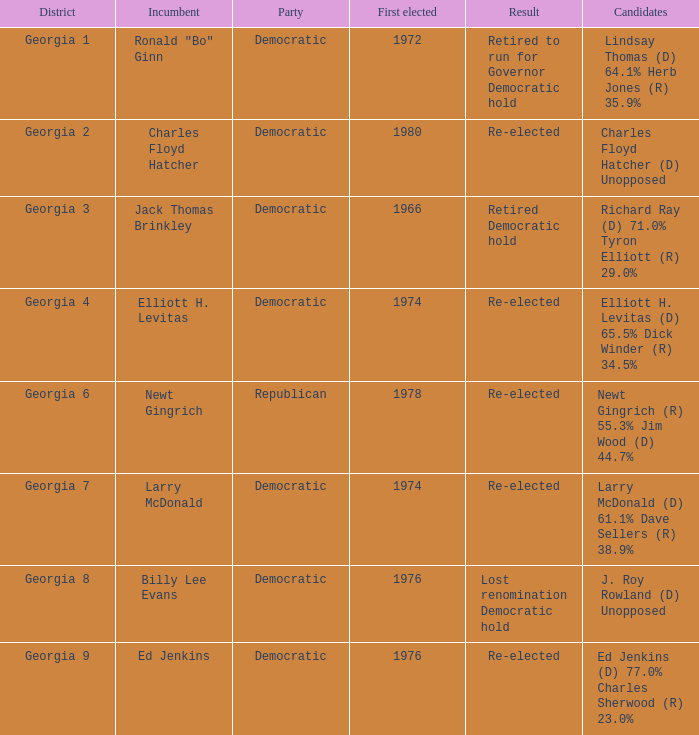Can you provide the party's name for jack thomas brinkley? Democratic. 